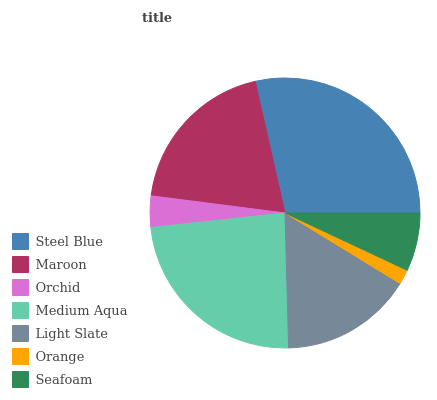Is Orange the minimum?
Answer yes or no. Yes. Is Steel Blue the maximum?
Answer yes or no. Yes. Is Maroon the minimum?
Answer yes or no. No. Is Maroon the maximum?
Answer yes or no. No. Is Steel Blue greater than Maroon?
Answer yes or no. Yes. Is Maroon less than Steel Blue?
Answer yes or no. Yes. Is Maroon greater than Steel Blue?
Answer yes or no. No. Is Steel Blue less than Maroon?
Answer yes or no. No. Is Light Slate the high median?
Answer yes or no. Yes. Is Light Slate the low median?
Answer yes or no. Yes. Is Steel Blue the high median?
Answer yes or no. No. Is Seafoam the low median?
Answer yes or no. No. 